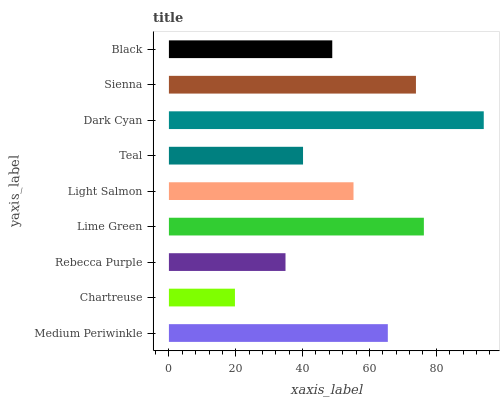Is Chartreuse the minimum?
Answer yes or no. Yes. Is Dark Cyan the maximum?
Answer yes or no. Yes. Is Rebecca Purple the minimum?
Answer yes or no. No. Is Rebecca Purple the maximum?
Answer yes or no. No. Is Rebecca Purple greater than Chartreuse?
Answer yes or no. Yes. Is Chartreuse less than Rebecca Purple?
Answer yes or no. Yes. Is Chartreuse greater than Rebecca Purple?
Answer yes or no. No. Is Rebecca Purple less than Chartreuse?
Answer yes or no. No. Is Light Salmon the high median?
Answer yes or no. Yes. Is Light Salmon the low median?
Answer yes or no. Yes. Is Medium Periwinkle the high median?
Answer yes or no. No. Is Lime Green the low median?
Answer yes or no. No. 